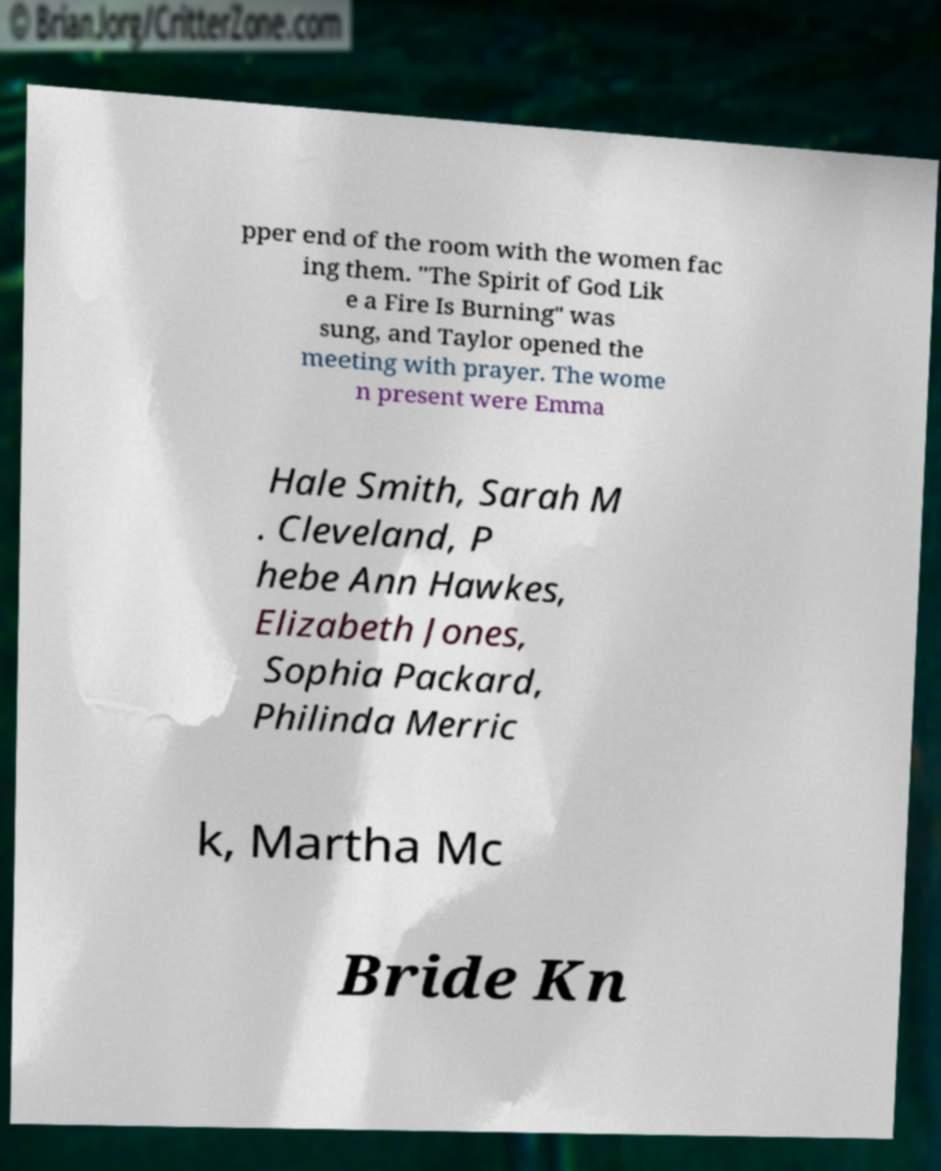Could you extract and type out the text from this image? pper end of the room with the women fac ing them. "The Spirit of God Lik e a Fire Is Burning" was sung, and Taylor opened the meeting with prayer. The wome n present were Emma Hale Smith, Sarah M . Cleveland, P hebe Ann Hawkes, Elizabeth Jones, Sophia Packard, Philinda Merric k, Martha Mc Bride Kn 